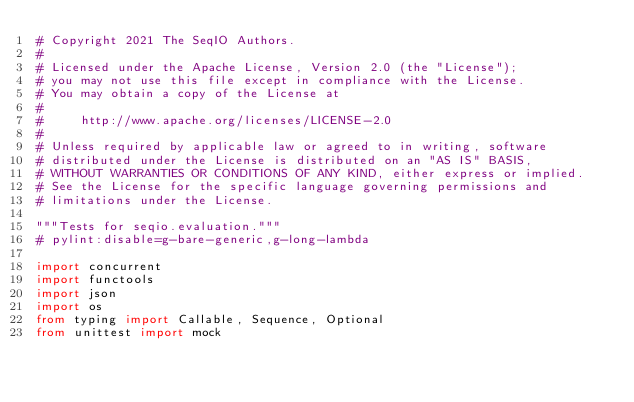Convert code to text. <code><loc_0><loc_0><loc_500><loc_500><_Python_># Copyright 2021 The SeqIO Authors.
#
# Licensed under the Apache License, Version 2.0 (the "License");
# you may not use this file except in compliance with the License.
# You may obtain a copy of the License at
#
#     http://www.apache.org/licenses/LICENSE-2.0
#
# Unless required by applicable law or agreed to in writing, software
# distributed under the License is distributed on an "AS IS" BASIS,
# WITHOUT WARRANTIES OR CONDITIONS OF ANY KIND, either express or implied.
# See the License for the specific language governing permissions and
# limitations under the License.

"""Tests for seqio.evaluation."""
# pylint:disable=g-bare-generic,g-long-lambda

import concurrent
import functools
import json
import os
from typing import Callable, Sequence, Optional
from unittest import mock
</code> 